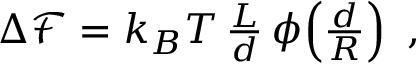<formula> <loc_0><loc_0><loc_500><loc_500>\begin{array} { r } { \Delta \mathcal { F } = k _ { B } T \, \frac { L } { d } \, \phi \, \left ( \frac { d } { R } \right ) , } \end{array}</formula> 